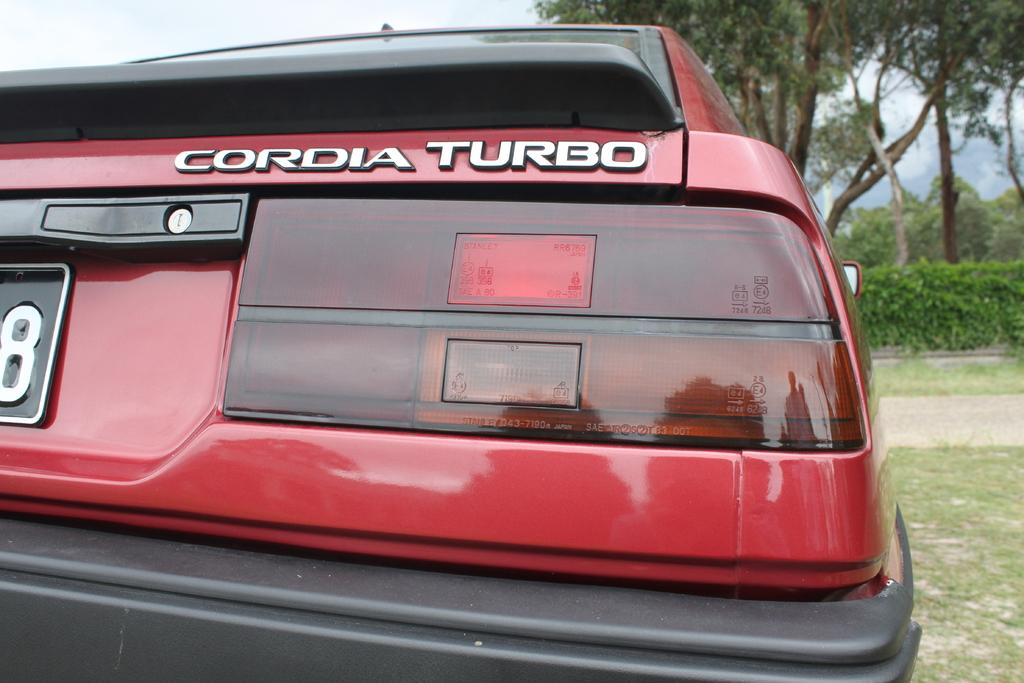<image>
Provide a brief description of the given image. a turbo label on the back of a red car 